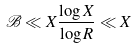<formula> <loc_0><loc_0><loc_500><loc_500>\mathcal { B } \ll X \frac { \log X } { \log R } \ll X</formula> 